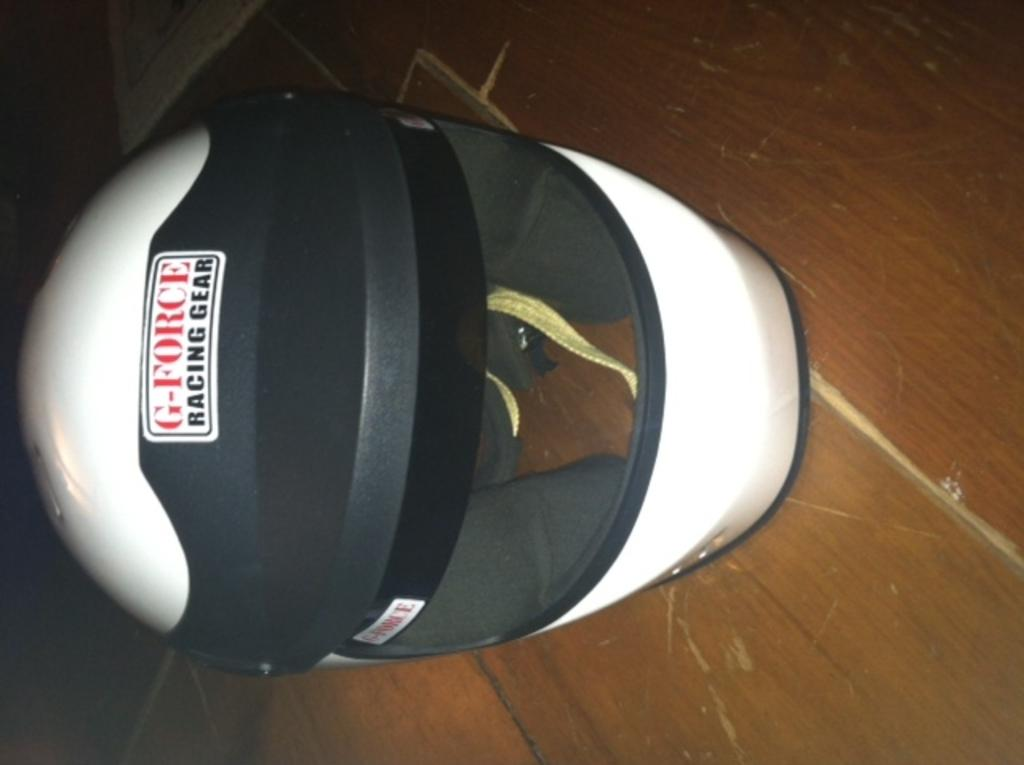What object is present on the floor in the image? There is a helmet placed on the floor in the image. Can you describe the position of the helmet in the image? The helmet is placed on the floor. What type of tramp can be seen in the image? There is no tramp present in the image; it only features a helmet placed on the floor. What kind of curve is visible in the image? There is no curve visible in the image; it only features a helmet placed on the floor. 